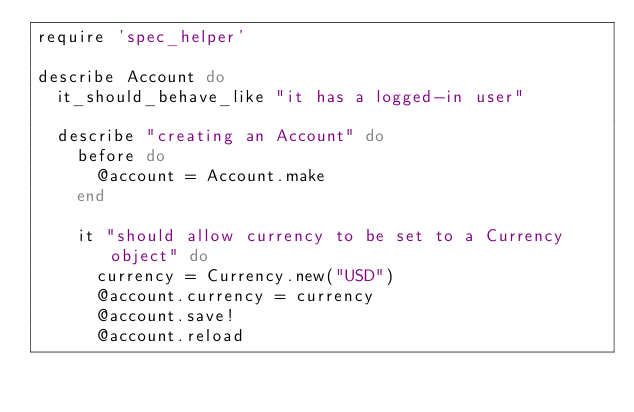Convert code to text. <code><loc_0><loc_0><loc_500><loc_500><_Ruby_>require 'spec_helper'

describe Account do
  it_should_behave_like "it has a logged-in user"

  describe "creating an Account" do
    before do
      @account = Account.make
    end

    it "should allow currency to be set to a Currency object" do
      currency = Currency.new("USD")
      @account.currency = currency
      @account.save!
      @account.reload</code> 